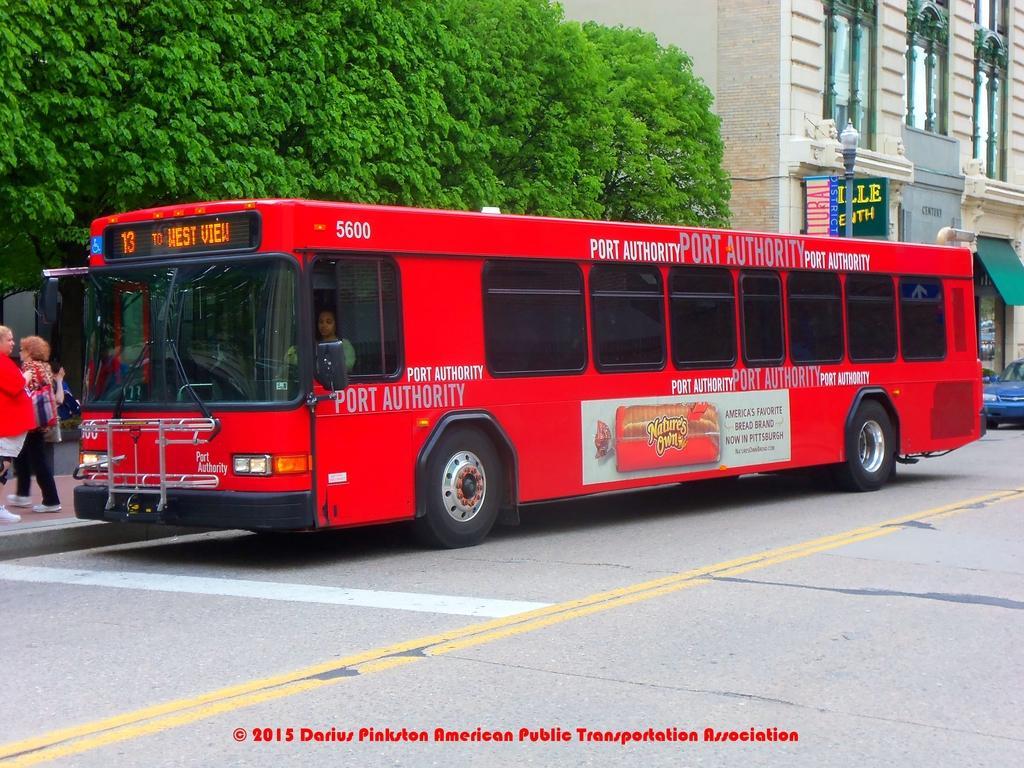How would you summarize this image in a sentence or two? In this image, we can see a bus and blue vehicle on the road. Here we can see a person is there inside the bus. On the left side of the image, we can see people are on the walkway. Background we can see trees, building, wall, pole, banners, stall and glass objects. At the bottom of the image, we can see the watermark in the image. 